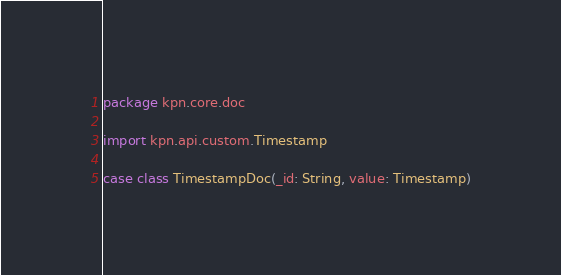<code> <loc_0><loc_0><loc_500><loc_500><_Scala_>package kpn.core.doc

import kpn.api.custom.Timestamp

case class TimestampDoc(_id: String, value: Timestamp)
</code> 